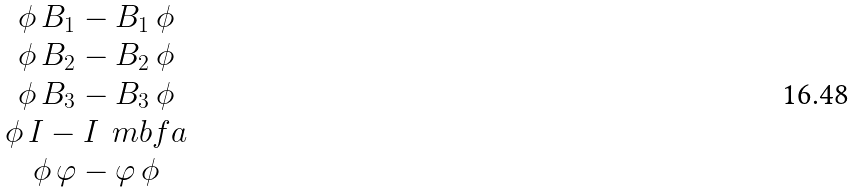Convert formula to latex. <formula><loc_0><loc_0><loc_500><loc_500>\begin{matrix} \phi \, B _ { 1 } - B _ { 1 } \, \phi \\ \phi \, B _ { 2 } - B _ { 2 } \, \phi \\ \phi \, B _ { 3 } - B _ { 3 } \, \phi \\ \phi \, I - I \, \ m b f a \\ \phi \, \varphi - \varphi \, \phi \end{matrix}</formula> 